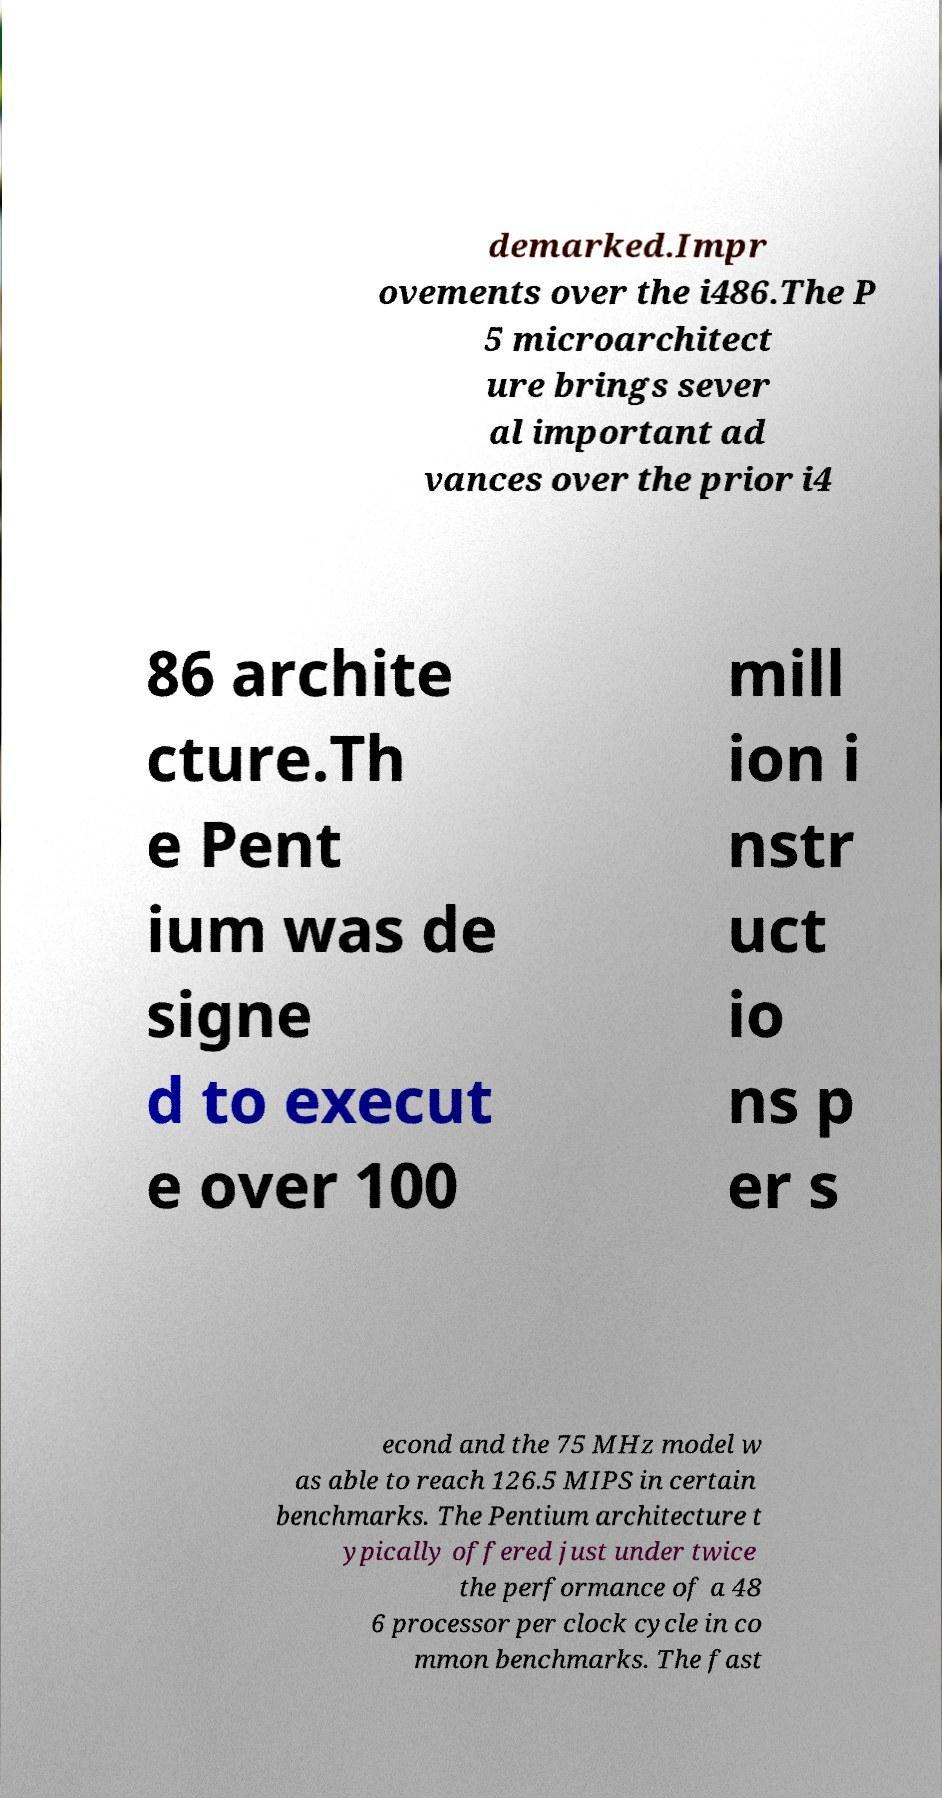For documentation purposes, I need the text within this image transcribed. Could you provide that? demarked.Impr ovements over the i486.The P 5 microarchitect ure brings sever al important ad vances over the prior i4 86 archite cture.Th e Pent ium was de signe d to execut e over 100 mill ion i nstr uct io ns p er s econd and the 75 MHz model w as able to reach 126.5 MIPS in certain benchmarks. The Pentium architecture t ypically offered just under twice the performance of a 48 6 processor per clock cycle in co mmon benchmarks. The fast 